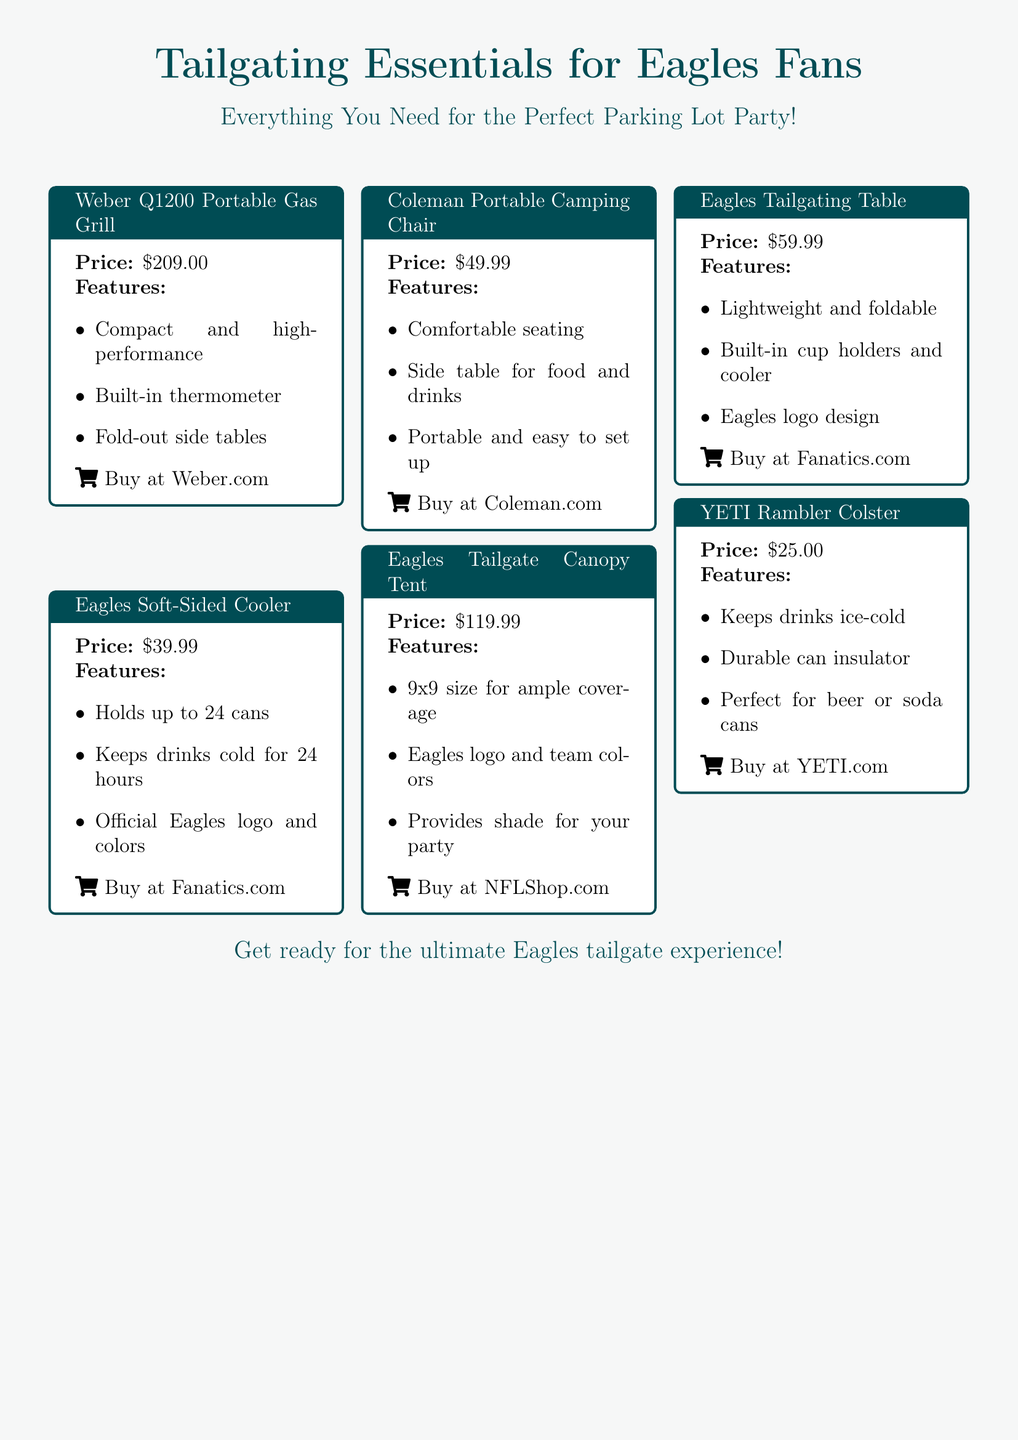What is the price of the Weber Q1200 Portable Gas Grill? The price is explicitly stated in the document as $209.00.
Answer: $209.00 What feature does the Eagles Soft-Sided Cooler provide? One of the features listed is that it keeps drinks cold for 24 hours.
Answer: Keeps drinks cold for 24 hours How much does the Coleman Portable Camping Chair cost? The document clearly lists the price of the chair as $49.99.
Answer: $49.99 What size is the Eagles Tailgate Canopy Tent? The size mentioned in the document is 9x9.
Answer: 9x9 Which product is the cheapest in the advertisement? The YETI Rambler Colster is listed as $25.00, which is the lowest price.
Answer: $25.00 What team logo is featured on the Eagles Tailgating Table? The table has the Eagles logo design indicated in the product description.
Answer: Eagles logo How many cans can the Eagles Soft-Sided Cooler hold? It is stated that the cooler holds up to 24 cans.
Answer: 24 cans What is a key feature of the Weber Q1200 Portable Gas Grill? The grill has a built-in thermometer, mentioned in the features.
Answer: Built-in thermometer Where can you buy the Eagles Tailgating Table? The document specifies that it can be purchased at Fanatics.com.
Answer: Fanatics.com 